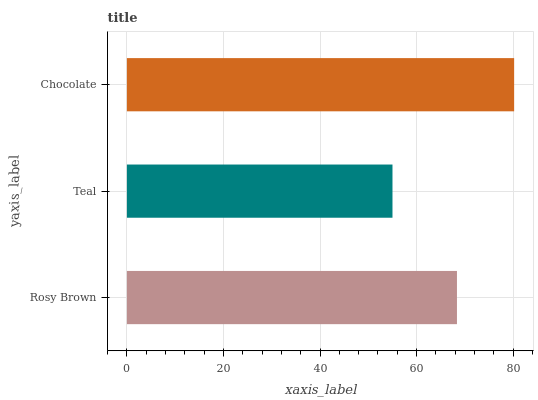Is Teal the minimum?
Answer yes or no. Yes. Is Chocolate the maximum?
Answer yes or no. Yes. Is Chocolate the minimum?
Answer yes or no. No. Is Teal the maximum?
Answer yes or no. No. Is Chocolate greater than Teal?
Answer yes or no. Yes. Is Teal less than Chocolate?
Answer yes or no. Yes. Is Teal greater than Chocolate?
Answer yes or no. No. Is Chocolate less than Teal?
Answer yes or no. No. Is Rosy Brown the high median?
Answer yes or no. Yes. Is Rosy Brown the low median?
Answer yes or no. Yes. Is Teal the high median?
Answer yes or no. No. Is Teal the low median?
Answer yes or no. No. 